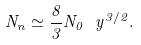<formula> <loc_0><loc_0><loc_500><loc_500>N _ { n } \simeq \frac { 8 } { 3 } N _ { 0 } \ y ^ { 3 / 2 } .</formula> 